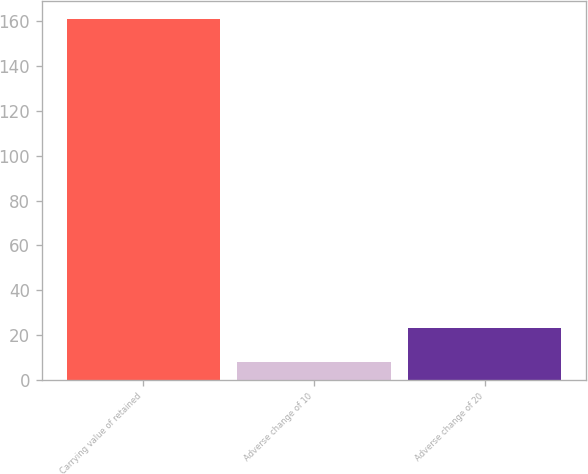Convert chart to OTSL. <chart><loc_0><loc_0><loc_500><loc_500><bar_chart><fcel>Carrying value of retained<fcel>Adverse change of 10<fcel>Adverse change of 20<nl><fcel>161<fcel>8<fcel>23.3<nl></chart> 